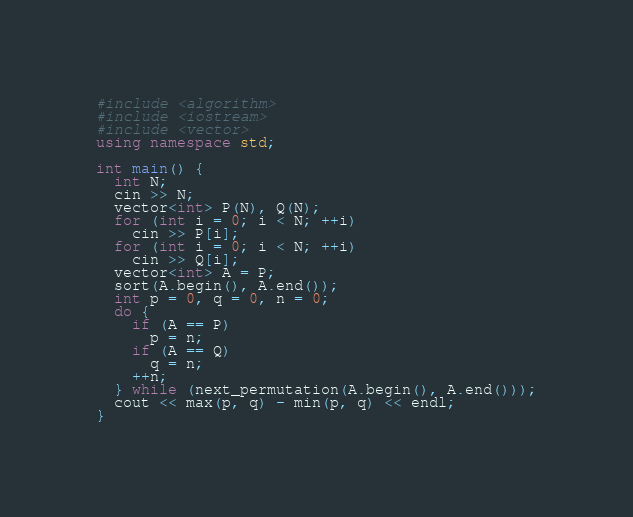<code> <loc_0><loc_0><loc_500><loc_500><_C++_>#include <algorithm>
#include <iostream>
#include <vector>
using namespace std;

int main() {
  int N;
  cin >> N;
  vector<int> P(N), Q(N);
  for (int i = 0; i < N; ++i)
    cin >> P[i];
  for (int i = 0; i < N; ++i)
    cin >> Q[i];
  vector<int> A = P;
  sort(A.begin(), A.end());
  int p = 0, q = 0, n = 0;
  do {
    if (A == P)
      p = n;
    if (A == Q)
      q = n;
    ++n;
  } while (next_permutation(A.begin(), A.end()));
  cout << max(p, q) - min(p, q) << endl;
}
</code> 